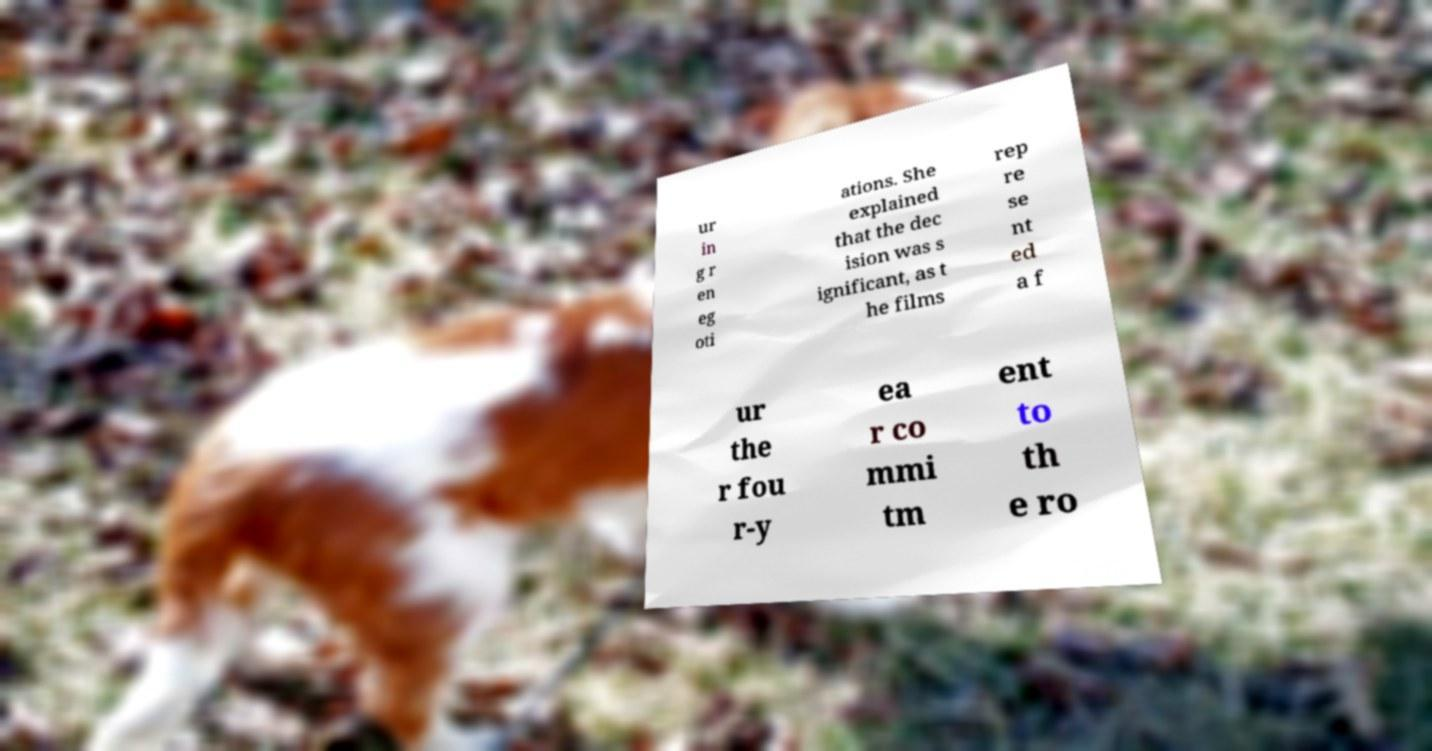Can you read and provide the text displayed in the image?This photo seems to have some interesting text. Can you extract and type it out for me? ur in g r en eg oti ations. She explained that the dec ision was s ignificant, as t he films rep re se nt ed a f ur the r fou r-y ea r co mmi tm ent to th e ro 